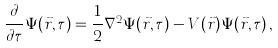Convert formula to latex. <formula><loc_0><loc_0><loc_500><loc_500>\frac { \partial } { \partial \tau } \Psi ( \vec { r } , \tau ) = \frac { 1 } { 2 } \nabla ^ { 2 } \Psi ( \vec { r } , \tau ) - V ( \vec { r } ) \Psi ( \vec { r } , \tau ) \, ,</formula> 